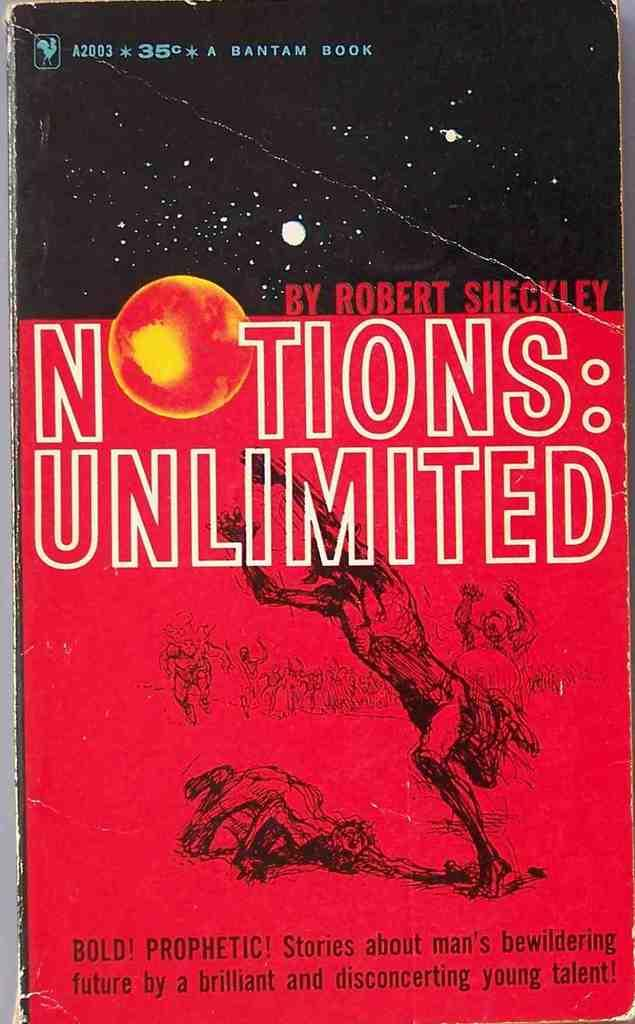<image>
Summarize the visual content of the image. paperback book notions: unlimited by robert sheckley has stories about man's future 